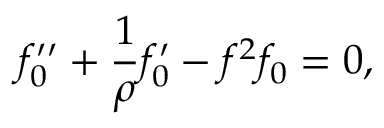Convert formula to latex. <formula><loc_0><loc_0><loc_500><loc_500>f _ { 0 } ^ { \prime \prime } + \frac { 1 } { \rho } f _ { 0 } ^ { \prime } - f ^ { 2 } f _ { 0 } = 0 ,</formula> 